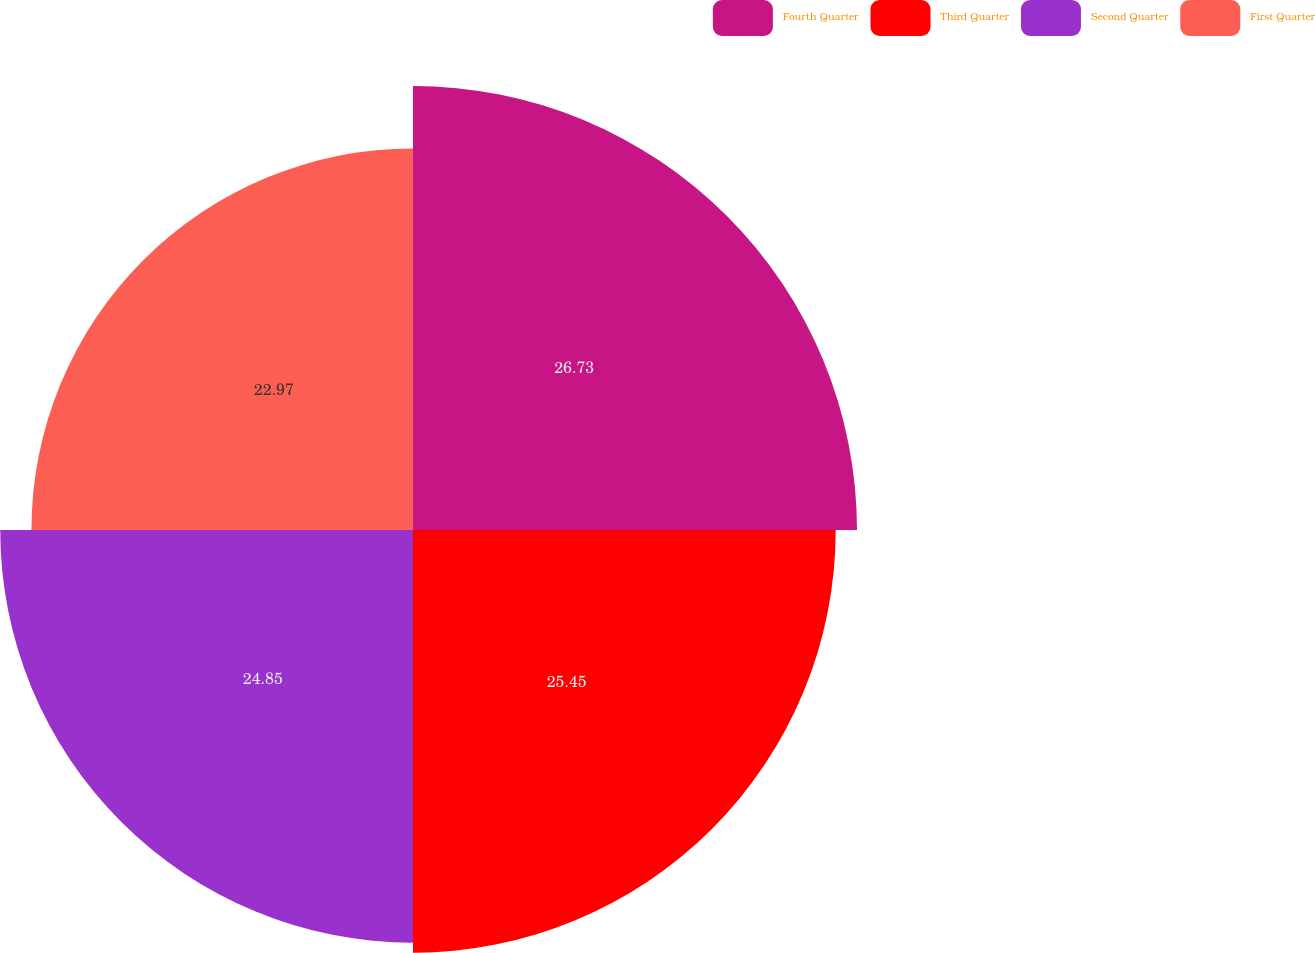Convert chart. <chart><loc_0><loc_0><loc_500><loc_500><pie_chart><fcel>Fourth Quarter<fcel>Third Quarter<fcel>Second Quarter<fcel>First Quarter<nl><fcel>26.73%<fcel>25.45%<fcel>24.85%<fcel>22.97%<nl></chart> 